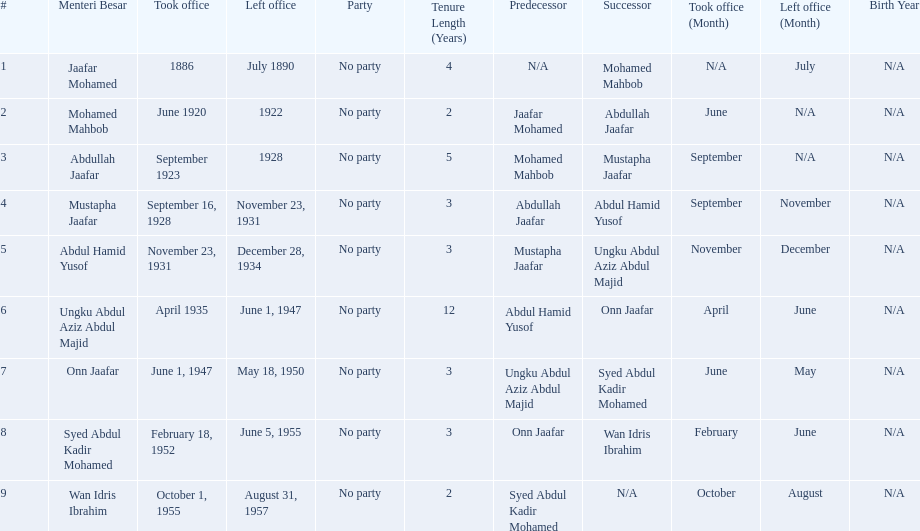Who are all of the menteri besars? Jaafar Mohamed, Mohamed Mahbob, Abdullah Jaafar, Mustapha Jaafar, Abdul Hamid Yusof, Ungku Abdul Aziz Abdul Majid, Onn Jaafar, Syed Abdul Kadir Mohamed, Wan Idris Ibrahim. When did each take office? 1886, June 1920, September 1923, September 16, 1928, November 23, 1931, April 1935, June 1, 1947, February 18, 1952, October 1, 1955. When did they leave? July 1890, 1922, 1928, November 23, 1931, December 28, 1934, June 1, 1947, May 18, 1950, June 5, 1955, August 31, 1957. And which spent the most time in office? Ungku Abdul Aziz Abdul Majid. 